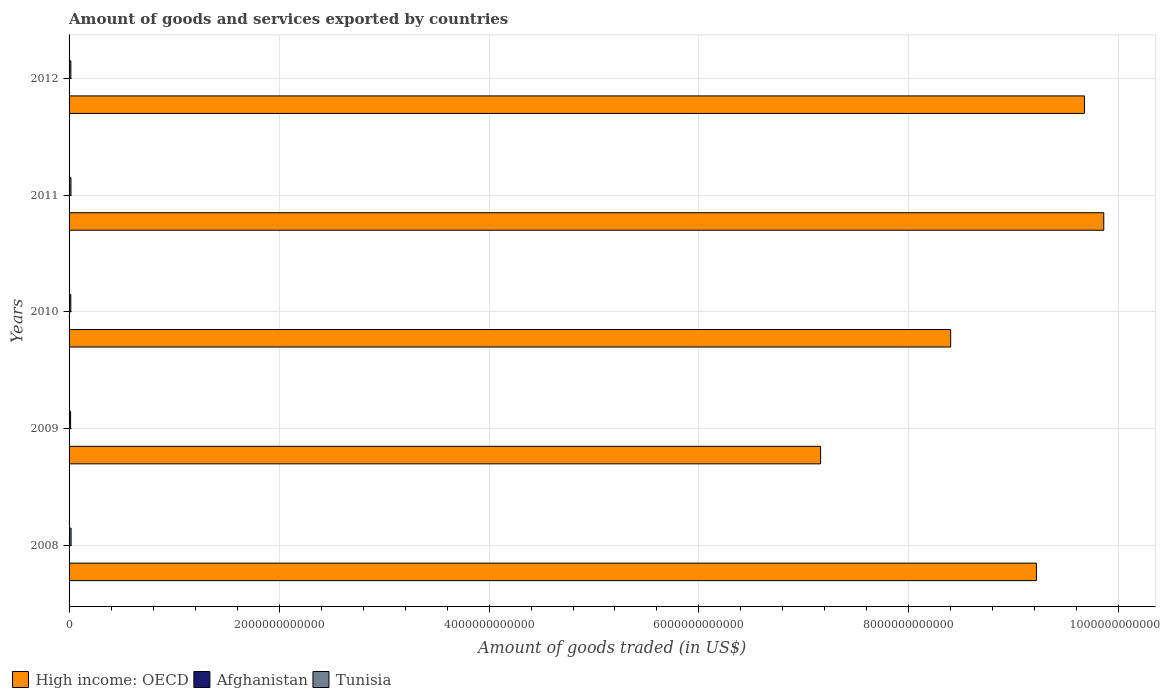Are the number of bars per tick equal to the number of legend labels?
Your answer should be compact. Yes. How many bars are there on the 3rd tick from the bottom?
Your response must be concise. 3. In how many cases, is the number of bars for a given year not equal to the number of legend labels?
Your response must be concise. 0. What is the total amount of goods and services exported in High income: OECD in 2010?
Keep it short and to the point. 8.40e+12. Across all years, what is the maximum total amount of goods and services exported in Afghanistan?
Your answer should be compact. 6.20e+08. Across all years, what is the minimum total amount of goods and services exported in Tunisia?
Your response must be concise. 1.45e+1. In which year was the total amount of goods and services exported in High income: OECD minimum?
Give a very brief answer. 2009. What is the total total amount of goods and services exported in High income: OECD in the graph?
Offer a very short reply. 4.43e+13. What is the difference between the total amount of goods and services exported in Afghanistan in 2009 and that in 2012?
Make the answer very short. -2.14e+08. What is the difference between the total amount of goods and services exported in High income: OECD in 2008 and the total amount of goods and services exported in Tunisia in 2012?
Give a very brief answer. 9.20e+12. What is the average total amount of goods and services exported in Tunisia per year?
Your answer should be very brief. 1.70e+1. In the year 2010, what is the difference between the total amount of goods and services exported in High income: OECD and total amount of goods and services exported in Tunisia?
Provide a short and direct response. 8.38e+12. In how many years, is the total amount of goods and services exported in Tunisia greater than 5200000000000 US$?
Provide a short and direct response. 0. What is the ratio of the total amount of goods and services exported in Tunisia in 2009 to that in 2012?
Give a very brief answer. 0.85. Is the total amount of goods and services exported in Afghanistan in 2008 less than that in 2009?
Your response must be concise. No. What is the difference between the highest and the second highest total amount of goods and services exported in Afghanistan?
Provide a short and direct response. 5.67e+07. What is the difference between the highest and the lowest total amount of goods and services exported in High income: OECD?
Your response must be concise. 2.70e+12. What does the 2nd bar from the top in 2010 represents?
Your answer should be very brief. Afghanistan. What does the 3rd bar from the bottom in 2011 represents?
Provide a short and direct response. Tunisia. Is it the case that in every year, the sum of the total amount of goods and services exported in High income: OECD and total amount of goods and services exported in Tunisia is greater than the total amount of goods and services exported in Afghanistan?
Keep it short and to the point. Yes. What is the difference between two consecutive major ticks on the X-axis?
Keep it short and to the point. 2.00e+12. Does the graph contain any zero values?
Offer a very short reply. No. How are the legend labels stacked?
Give a very brief answer. Horizontal. What is the title of the graph?
Provide a short and direct response. Amount of goods and services exported by countries. What is the label or title of the X-axis?
Offer a terse response. Amount of goods traded (in US$). What is the label or title of the Y-axis?
Provide a short and direct response. Years. What is the Amount of goods traded (in US$) in High income: OECD in 2008?
Your answer should be compact. 9.21e+12. What is the Amount of goods traded (in US$) of Afghanistan in 2008?
Give a very brief answer. 5.63e+08. What is the Amount of goods traded (in US$) of Tunisia in 2008?
Your answer should be compact. 1.92e+1. What is the Amount of goods traded (in US$) in High income: OECD in 2009?
Provide a succinct answer. 7.16e+12. What is the Amount of goods traded (in US$) of Afghanistan in 2009?
Keep it short and to the point. 4.06e+08. What is the Amount of goods traded (in US$) of Tunisia in 2009?
Ensure brevity in your answer.  1.45e+1. What is the Amount of goods traded (in US$) in High income: OECD in 2010?
Keep it short and to the point. 8.40e+12. What is the Amount of goods traded (in US$) of Afghanistan in 2010?
Ensure brevity in your answer.  4.53e+08. What is the Amount of goods traded (in US$) in Tunisia in 2010?
Give a very brief answer. 1.65e+1. What is the Amount of goods traded (in US$) of High income: OECD in 2011?
Provide a short and direct response. 9.86e+12. What is the Amount of goods traded (in US$) of Afghanistan in 2011?
Provide a succinct answer. 4.31e+08. What is the Amount of goods traded (in US$) in Tunisia in 2011?
Make the answer very short. 1.79e+1. What is the Amount of goods traded (in US$) in High income: OECD in 2012?
Offer a terse response. 9.67e+12. What is the Amount of goods traded (in US$) of Afghanistan in 2012?
Offer a very short reply. 6.20e+08. What is the Amount of goods traded (in US$) in Tunisia in 2012?
Make the answer very short. 1.71e+1. Across all years, what is the maximum Amount of goods traded (in US$) of High income: OECD?
Provide a short and direct response. 9.86e+12. Across all years, what is the maximum Amount of goods traded (in US$) in Afghanistan?
Ensure brevity in your answer.  6.20e+08. Across all years, what is the maximum Amount of goods traded (in US$) in Tunisia?
Your answer should be very brief. 1.92e+1. Across all years, what is the minimum Amount of goods traded (in US$) of High income: OECD?
Provide a short and direct response. 7.16e+12. Across all years, what is the minimum Amount of goods traded (in US$) of Afghanistan?
Your answer should be compact. 4.06e+08. Across all years, what is the minimum Amount of goods traded (in US$) in Tunisia?
Keep it short and to the point. 1.45e+1. What is the total Amount of goods traded (in US$) of High income: OECD in the graph?
Ensure brevity in your answer.  4.43e+13. What is the total Amount of goods traded (in US$) in Afghanistan in the graph?
Offer a very short reply. 2.47e+09. What is the total Amount of goods traded (in US$) in Tunisia in the graph?
Provide a short and direct response. 8.52e+1. What is the difference between the Amount of goods traded (in US$) in High income: OECD in 2008 and that in 2009?
Offer a terse response. 2.06e+12. What is the difference between the Amount of goods traded (in US$) of Afghanistan in 2008 and that in 2009?
Offer a very short reply. 1.57e+08. What is the difference between the Amount of goods traded (in US$) in Tunisia in 2008 and that in 2009?
Keep it short and to the point. 4.77e+09. What is the difference between the Amount of goods traded (in US$) of High income: OECD in 2008 and that in 2010?
Provide a short and direct response. 8.17e+11. What is the difference between the Amount of goods traded (in US$) in Afghanistan in 2008 and that in 2010?
Ensure brevity in your answer.  1.10e+08. What is the difference between the Amount of goods traded (in US$) in Tunisia in 2008 and that in 2010?
Provide a short and direct response. 2.76e+09. What is the difference between the Amount of goods traded (in US$) in High income: OECD in 2008 and that in 2011?
Your answer should be compact. -6.41e+11. What is the difference between the Amount of goods traded (in US$) in Afghanistan in 2008 and that in 2011?
Make the answer very short. 1.32e+08. What is the difference between the Amount of goods traded (in US$) of Tunisia in 2008 and that in 2011?
Your answer should be very brief. 1.37e+09. What is the difference between the Amount of goods traded (in US$) in High income: OECD in 2008 and that in 2012?
Give a very brief answer. -4.58e+11. What is the difference between the Amount of goods traded (in US$) in Afghanistan in 2008 and that in 2012?
Offer a terse response. -5.67e+07. What is the difference between the Amount of goods traded (in US$) in Tunisia in 2008 and that in 2012?
Keep it short and to the point. 2.18e+09. What is the difference between the Amount of goods traded (in US$) of High income: OECD in 2009 and that in 2010?
Offer a terse response. -1.24e+12. What is the difference between the Amount of goods traded (in US$) of Afghanistan in 2009 and that in 2010?
Ensure brevity in your answer.  -4.72e+07. What is the difference between the Amount of goods traded (in US$) in Tunisia in 2009 and that in 2010?
Offer a terse response. -2.01e+09. What is the difference between the Amount of goods traded (in US$) of High income: OECD in 2009 and that in 2011?
Make the answer very short. -2.70e+12. What is the difference between the Amount of goods traded (in US$) of Afghanistan in 2009 and that in 2011?
Make the answer very short. -2.45e+07. What is the difference between the Amount of goods traded (in US$) of Tunisia in 2009 and that in 2011?
Your answer should be compact. -3.39e+09. What is the difference between the Amount of goods traded (in US$) of High income: OECD in 2009 and that in 2012?
Provide a succinct answer. -2.51e+12. What is the difference between the Amount of goods traded (in US$) of Afghanistan in 2009 and that in 2012?
Give a very brief answer. -2.14e+08. What is the difference between the Amount of goods traded (in US$) of Tunisia in 2009 and that in 2012?
Keep it short and to the point. -2.59e+09. What is the difference between the Amount of goods traded (in US$) in High income: OECD in 2010 and that in 2011?
Offer a terse response. -1.46e+12. What is the difference between the Amount of goods traded (in US$) of Afghanistan in 2010 and that in 2011?
Keep it short and to the point. 2.27e+07. What is the difference between the Amount of goods traded (in US$) of Tunisia in 2010 and that in 2011?
Your response must be concise. -1.38e+09. What is the difference between the Amount of goods traded (in US$) in High income: OECD in 2010 and that in 2012?
Provide a succinct answer. -1.27e+12. What is the difference between the Amount of goods traded (in US$) of Afghanistan in 2010 and that in 2012?
Offer a terse response. -1.66e+08. What is the difference between the Amount of goods traded (in US$) in Tunisia in 2010 and that in 2012?
Your response must be concise. -5.78e+08. What is the difference between the Amount of goods traded (in US$) in High income: OECD in 2011 and that in 2012?
Make the answer very short. 1.84e+11. What is the difference between the Amount of goods traded (in US$) of Afghanistan in 2011 and that in 2012?
Offer a terse response. -1.89e+08. What is the difference between the Amount of goods traded (in US$) of Tunisia in 2011 and that in 2012?
Provide a short and direct response. 8.05e+08. What is the difference between the Amount of goods traded (in US$) of High income: OECD in 2008 and the Amount of goods traded (in US$) of Afghanistan in 2009?
Provide a succinct answer. 9.21e+12. What is the difference between the Amount of goods traded (in US$) in High income: OECD in 2008 and the Amount of goods traded (in US$) in Tunisia in 2009?
Your answer should be very brief. 9.20e+12. What is the difference between the Amount of goods traded (in US$) of Afghanistan in 2008 and the Amount of goods traded (in US$) of Tunisia in 2009?
Your response must be concise. -1.39e+1. What is the difference between the Amount of goods traded (in US$) of High income: OECD in 2008 and the Amount of goods traded (in US$) of Afghanistan in 2010?
Your response must be concise. 9.21e+12. What is the difference between the Amount of goods traded (in US$) in High income: OECD in 2008 and the Amount of goods traded (in US$) in Tunisia in 2010?
Keep it short and to the point. 9.20e+12. What is the difference between the Amount of goods traded (in US$) in Afghanistan in 2008 and the Amount of goods traded (in US$) in Tunisia in 2010?
Your response must be concise. -1.59e+1. What is the difference between the Amount of goods traded (in US$) in High income: OECD in 2008 and the Amount of goods traded (in US$) in Afghanistan in 2011?
Offer a terse response. 9.21e+12. What is the difference between the Amount of goods traded (in US$) of High income: OECD in 2008 and the Amount of goods traded (in US$) of Tunisia in 2011?
Offer a terse response. 9.20e+12. What is the difference between the Amount of goods traded (in US$) of Afghanistan in 2008 and the Amount of goods traded (in US$) of Tunisia in 2011?
Your answer should be compact. -1.73e+1. What is the difference between the Amount of goods traded (in US$) of High income: OECD in 2008 and the Amount of goods traded (in US$) of Afghanistan in 2012?
Offer a terse response. 9.21e+12. What is the difference between the Amount of goods traded (in US$) of High income: OECD in 2008 and the Amount of goods traded (in US$) of Tunisia in 2012?
Offer a very short reply. 9.20e+12. What is the difference between the Amount of goods traded (in US$) in Afghanistan in 2008 and the Amount of goods traded (in US$) in Tunisia in 2012?
Make the answer very short. -1.65e+1. What is the difference between the Amount of goods traded (in US$) in High income: OECD in 2009 and the Amount of goods traded (in US$) in Afghanistan in 2010?
Keep it short and to the point. 7.16e+12. What is the difference between the Amount of goods traded (in US$) of High income: OECD in 2009 and the Amount of goods traded (in US$) of Tunisia in 2010?
Provide a succinct answer. 7.14e+12. What is the difference between the Amount of goods traded (in US$) of Afghanistan in 2009 and the Amount of goods traded (in US$) of Tunisia in 2010?
Ensure brevity in your answer.  -1.61e+1. What is the difference between the Amount of goods traded (in US$) of High income: OECD in 2009 and the Amount of goods traded (in US$) of Afghanistan in 2011?
Your answer should be very brief. 7.16e+12. What is the difference between the Amount of goods traded (in US$) in High income: OECD in 2009 and the Amount of goods traded (in US$) in Tunisia in 2011?
Offer a very short reply. 7.14e+12. What is the difference between the Amount of goods traded (in US$) in Afghanistan in 2009 and the Amount of goods traded (in US$) in Tunisia in 2011?
Make the answer very short. -1.75e+1. What is the difference between the Amount of goods traded (in US$) of High income: OECD in 2009 and the Amount of goods traded (in US$) of Afghanistan in 2012?
Offer a very short reply. 7.16e+12. What is the difference between the Amount of goods traded (in US$) of High income: OECD in 2009 and the Amount of goods traded (in US$) of Tunisia in 2012?
Keep it short and to the point. 7.14e+12. What is the difference between the Amount of goods traded (in US$) of Afghanistan in 2009 and the Amount of goods traded (in US$) of Tunisia in 2012?
Offer a very short reply. -1.67e+1. What is the difference between the Amount of goods traded (in US$) of High income: OECD in 2010 and the Amount of goods traded (in US$) of Afghanistan in 2011?
Give a very brief answer. 8.40e+12. What is the difference between the Amount of goods traded (in US$) of High income: OECD in 2010 and the Amount of goods traded (in US$) of Tunisia in 2011?
Your answer should be very brief. 8.38e+12. What is the difference between the Amount of goods traded (in US$) in Afghanistan in 2010 and the Amount of goods traded (in US$) in Tunisia in 2011?
Keep it short and to the point. -1.74e+1. What is the difference between the Amount of goods traded (in US$) of High income: OECD in 2010 and the Amount of goods traded (in US$) of Afghanistan in 2012?
Give a very brief answer. 8.40e+12. What is the difference between the Amount of goods traded (in US$) in High income: OECD in 2010 and the Amount of goods traded (in US$) in Tunisia in 2012?
Your answer should be compact. 8.38e+12. What is the difference between the Amount of goods traded (in US$) in Afghanistan in 2010 and the Amount of goods traded (in US$) in Tunisia in 2012?
Provide a short and direct response. -1.66e+1. What is the difference between the Amount of goods traded (in US$) of High income: OECD in 2011 and the Amount of goods traded (in US$) of Afghanistan in 2012?
Offer a terse response. 9.86e+12. What is the difference between the Amount of goods traded (in US$) in High income: OECD in 2011 and the Amount of goods traded (in US$) in Tunisia in 2012?
Keep it short and to the point. 9.84e+12. What is the difference between the Amount of goods traded (in US$) of Afghanistan in 2011 and the Amount of goods traded (in US$) of Tunisia in 2012?
Ensure brevity in your answer.  -1.66e+1. What is the average Amount of goods traded (in US$) of High income: OECD per year?
Keep it short and to the point. 8.86e+12. What is the average Amount of goods traded (in US$) in Afghanistan per year?
Keep it short and to the point. 4.95e+08. What is the average Amount of goods traded (in US$) in Tunisia per year?
Make the answer very short. 1.70e+1. In the year 2008, what is the difference between the Amount of goods traded (in US$) of High income: OECD and Amount of goods traded (in US$) of Afghanistan?
Your response must be concise. 9.21e+12. In the year 2008, what is the difference between the Amount of goods traded (in US$) in High income: OECD and Amount of goods traded (in US$) in Tunisia?
Provide a short and direct response. 9.20e+12. In the year 2008, what is the difference between the Amount of goods traded (in US$) of Afghanistan and Amount of goods traded (in US$) of Tunisia?
Keep it short and to the point. -1.87e+1. In the year 2009, what is the difference between the Amount of goods traded (in US$) of High income: OECD and Amount of goods traded (in US$) of Afghanistan?
Offer a very short reply. 7.16e+12. In the year 2009, what is the difference between the Amount of goods traded (in US$) of High income: OECD and Amount of goods traded (in US$) of Tunisia?
Ensure brevity in your answer.  7.14e+12. In the year 2009, what is the difference between the Amount of goods traded (in US$) in Afghanistan and Amount of goods traded (in US$) in Tunisia?
Your answer should be very brief. -1.41e+1. In the year 2010, what is the difference between the Amount of goods traded (in US$) of High income: OECD and Amount of goods traded (in US$) of Afghanistan?
Your response must be concise. 8.40e+12. In the year 2010, what is the difference between the Amount of goods traded (in US$) in High income: OECD and Amount of goods traded (in US$) in Tunisia?
Your answer should be compact. 8.38e+12. In the year 2010, what is the difference between the Amount of goods traded (in US$) of Afghanistan and Amount of goods traded (in US$) of Tunisia?
Your answer should be very brief. -1.60e+1. In the year 2011, what is the difference between the Amount of goods traded (in US$) in High income: OECD and Amount of goods traded (in US$) in Afghanistan?
Provide a succinct answer. 9.86e+12. In the year 2011, what is the difference between the Amount of goods traded (in US$) of High income: OECD and Amount of goods traded (in US$) of Tunisia?
Keep it short and to the point. 9.84e+12. In the year 2011, what is the difference between the Amount of goods traded (in US$) of Afghanistan and Amount of goods traded (in US$) of Tunisia?
Offer a terse response. -1.74e+1. In the year 2012, what is the difference between the Amount of goods traded (in US$) of High income: OECD and Amount of goods traded (in US$) of Afghanistan?
Keep it short and to the point. 9.67e+12. In the year 2012, what is the difference between the Amount of goods traded (in US$) of High income: OECD and Amount of goods traded (in US$) of Tunisia?
Give a very brief answer. 9.65e+12. In the year 2012, what is the difference between the Amount of goods traded (in US$) in Afghanistan and Amount of goods traded (in US$) in Tunisia?
Provide a short and direct response. -1.65e+1. What is the ratio of the Amount of goods traded (in US$) in High income: OECD in 2008 to that in 2009?
Keep it short and to the point. 1.29. What is the ratio of the Amount of goods traded (in US$) of Afghanistan in 2008 to that in 2009?
Offer a terse response. 1.39. What is the ratio of the Amount of goods traded (in US$) in Tunisia in 2008 to that in 2009?
Keep it short and to the point. 1.33. What is the ratio of the Amount of goods traded (in US$) in High income: OECD in 2008 to that in 2010?
Keep it short and to the point. 1.1. What is the ratio of the Amount of goods traded (in US$) in Afghanistan in 2008 to that in 2010?
Offer a very short reply. 1.24. What is the ratio of the Amount of goods traded (in US$) of Tunisia in 2008 to that in 2010?
Your answer should be compact. 1.17. What is the ratio of the Amount of goods traded (in US$) in High income: OECD in 2008 to that in 2011?
Offer a very short reply. 0.93. What is the ratio of the Amount of goods traded (in US$) in Afghanistan in 2008 to that in 2011?
Ensure brevity in your answer.  1.31. What is the ratio of the Amount of goods traded (in US$) of Tunisia in 2008 to that in 2011?
Ensure brevity in your answer.  1.08. What is the ratio of the Amount of goods traded (in US$) in High income: OECD in 2008 to that in 2012?
Provide a succinct answer. 0.95. What is the ratio of the Amount of goods traded (in US$) of Afghanistan in 2008 to that in 2012?
Ensure brevity in your answer.  0.91. What is the ratio of the Amount of goods traded (in US$) in Tunisia in 2008 to that in 2012?
Keep it short and to the point. 1.13. What is the ratio of the Amount of goods traded (in US$) of High income: OECD in 2009 to that in 2010?
Give a very brief answer. 0.85. What is the ratio of the Amount of goods traded (in US$) of Afghanistan in 2009 to that in 2010?
Give a very brief answer. 0.9. What is the ratio of the Amount of goods traded (in US$) in Tunisia in 2009 to that in 2010?
Provide a short and direct response. 0.88. What is the ratio of the Amount of goods traded (in US$) in High income: OECD in 2009 to that in 2011?
Offer a terse response. 0.73. What is the ratio of the Amount of goods traded (in US$) in Afghanistan in 2009 to that in 2011?
Offer a very short reply. 0.94. What is the ratio of the Amount of goods traded (in US$) in Tunisia in 2009 to that in 2011?
Offer a very short reply. 0.81. What is the ratio of the Amount of goods traded (in US$) of High income: OECD in 2009 to that in 2012?
Give a very brief answer. 0.74. What is the ratio of the Amount of goods traded (in US$) of Afghanistan in 2009 to that in 2012?
Ensure brevity in your answer.  0.66. What is the ratio of the Amount of goods traded (in US$) in Tunisia in 2009 to that in 2012?
Your response must be concise. 0.85. What is the ratio of the Amount of goods traded (in US$) in High income: OECD in 2010 to that in 2011?
Make the answer very short. 0.85. What is the ratio of the Amount of goods traded (in US$) in Afghanistan in 2010 to that in 2011?
Your answer should be very brief. 1.05. What is the ratio of the Amount of goods traded (in US$) of Tunisia in 2010 to that in 2011?
Offer a terse response. 0.92. What is the ratio of the Amount of goods traded (in US$) in High income: OECD in 2010 to that in 2012?
Offer a terse response. 0.87. What is the ratio of the Amount of goods traded (in US$) of Afghanistan in 2010 to that in 2012?
Your response must be concise. 0.73. What is the ratio of the Amount of goods traded (in US$) of Tunisia in 2010 to that in 2012?
Provide a succinct answer. 0.97. What is the ratio of the Amount of goods traded (in US$) of High income: OECD in 2011 to that in 2012?
Your response must be concise. 1.02. What is the ratio of the Amount of goods traded (in US$) of Afghanistan in 2011 to that in 2012?
Offer a terse response. 0.69. What is the ratio of the Amount of goods traded (in US$) of Tunisia in 2011 to that in 2012?
Keep it short and to the point. 1.05. What is the difference between the highest and the second highest Amount of goods traded (in US$) in High income: OECD?
Your answer should be compact. 1.84e+11. What is the difference between the highest and the second highest Amount of goods traded (in US$) in Afghanistan?
Offer a terse response. 5.67e+07. What is the difference between the highest and the second highest Amount of goods traded (in US$) in Tunisia?
Make the answer very short. 1.37e+09. What is the difference between the highest and the lowest Amount of goods traded (in US$) in High income: OECD?
Provide a succinct answer. 2.70e+12. What is the difference between the highest and the lowest Amount of goods traded (in US$) in Afghanistan?
Your answer should be very brief. 2.14e+08. What is the difference between the highest and the lowest Amount of goods traded (in US$) in Tunisia?
Offer a very short reply. 4.77e+09. 